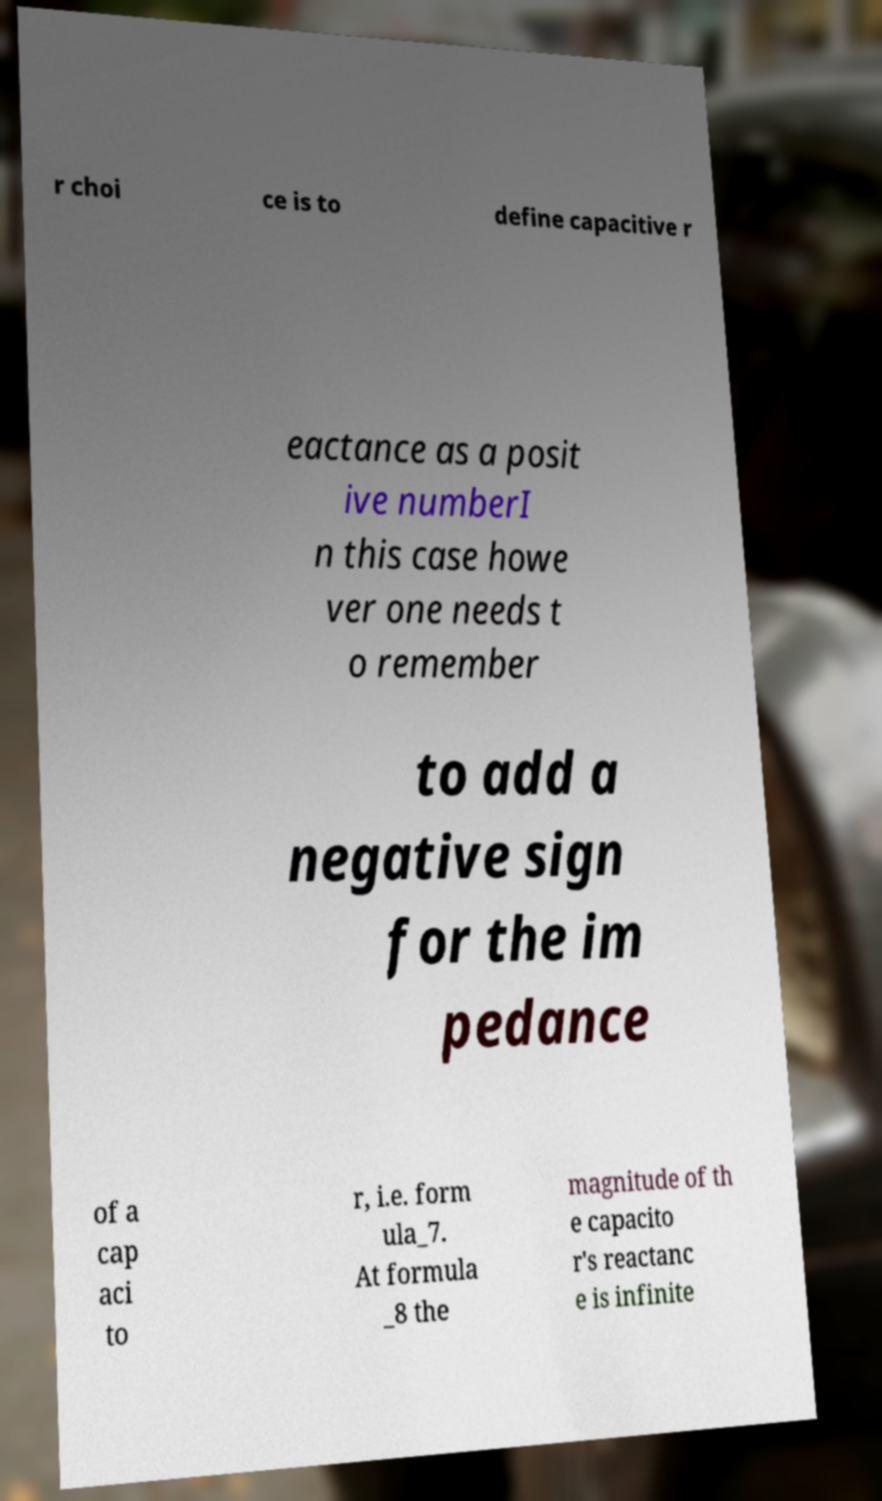Please identify and transcribe the text found in this image. r choi ce is to define capacitive r eactance as a posit ive numberI n this case howe ver one needs t o remember to add a negative sign for the im pedance of a cap aci to r, i.e. form ula_7. At formula _8 the magnitude of th e capacito r's reactanc e is infinite 